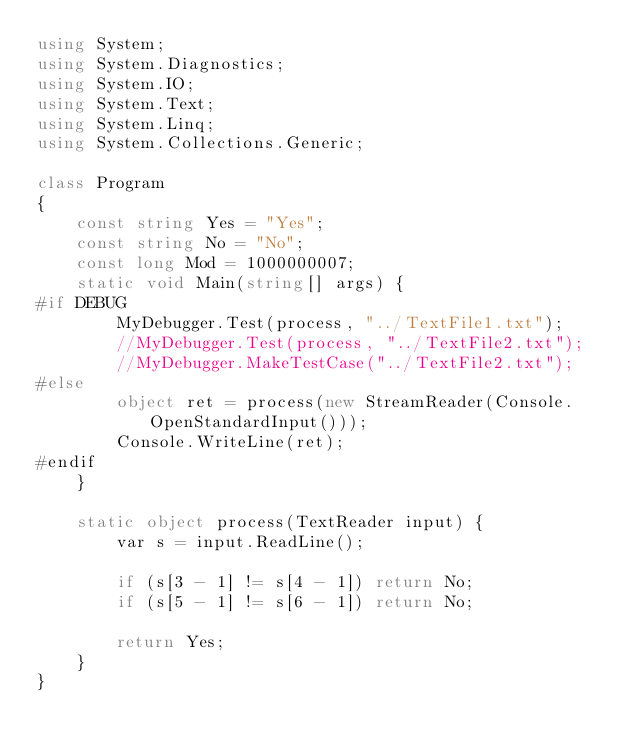<code> <loc_0><loc_0><loc_500><loc_500><_C#_>using System;
using System.Diagnostics;
using System.IO;
using System.Text;
using System.Linq;
using System.Collections.Generic;

class Program
{
    const string Yes = "Yes";
    const string No = "No";
    const long Mod = 1000000007;
    static void Main(string[] args) {
#if DEBUG
        MyDebugger.Test(process, "../TextFile1.txt");
        //MyDebugger.Test(process, "../TextFile2.txt");
        //MyDebugger.MakeTestCase("../TextFile2.txt");
#else
        object ret = process(new StreamReader(Console.OpenStandardInput()));
        Console.WriteLine(ret);
#endif
    }

    static object process(TextReader input) {
        var s = input.ReadLine();

        if (s[3 - 1] != s[4 - 1]) return No;
        if (s[5 - 1] != s[6 - 1]) return No;

        return Yes;
    }
}</code> 